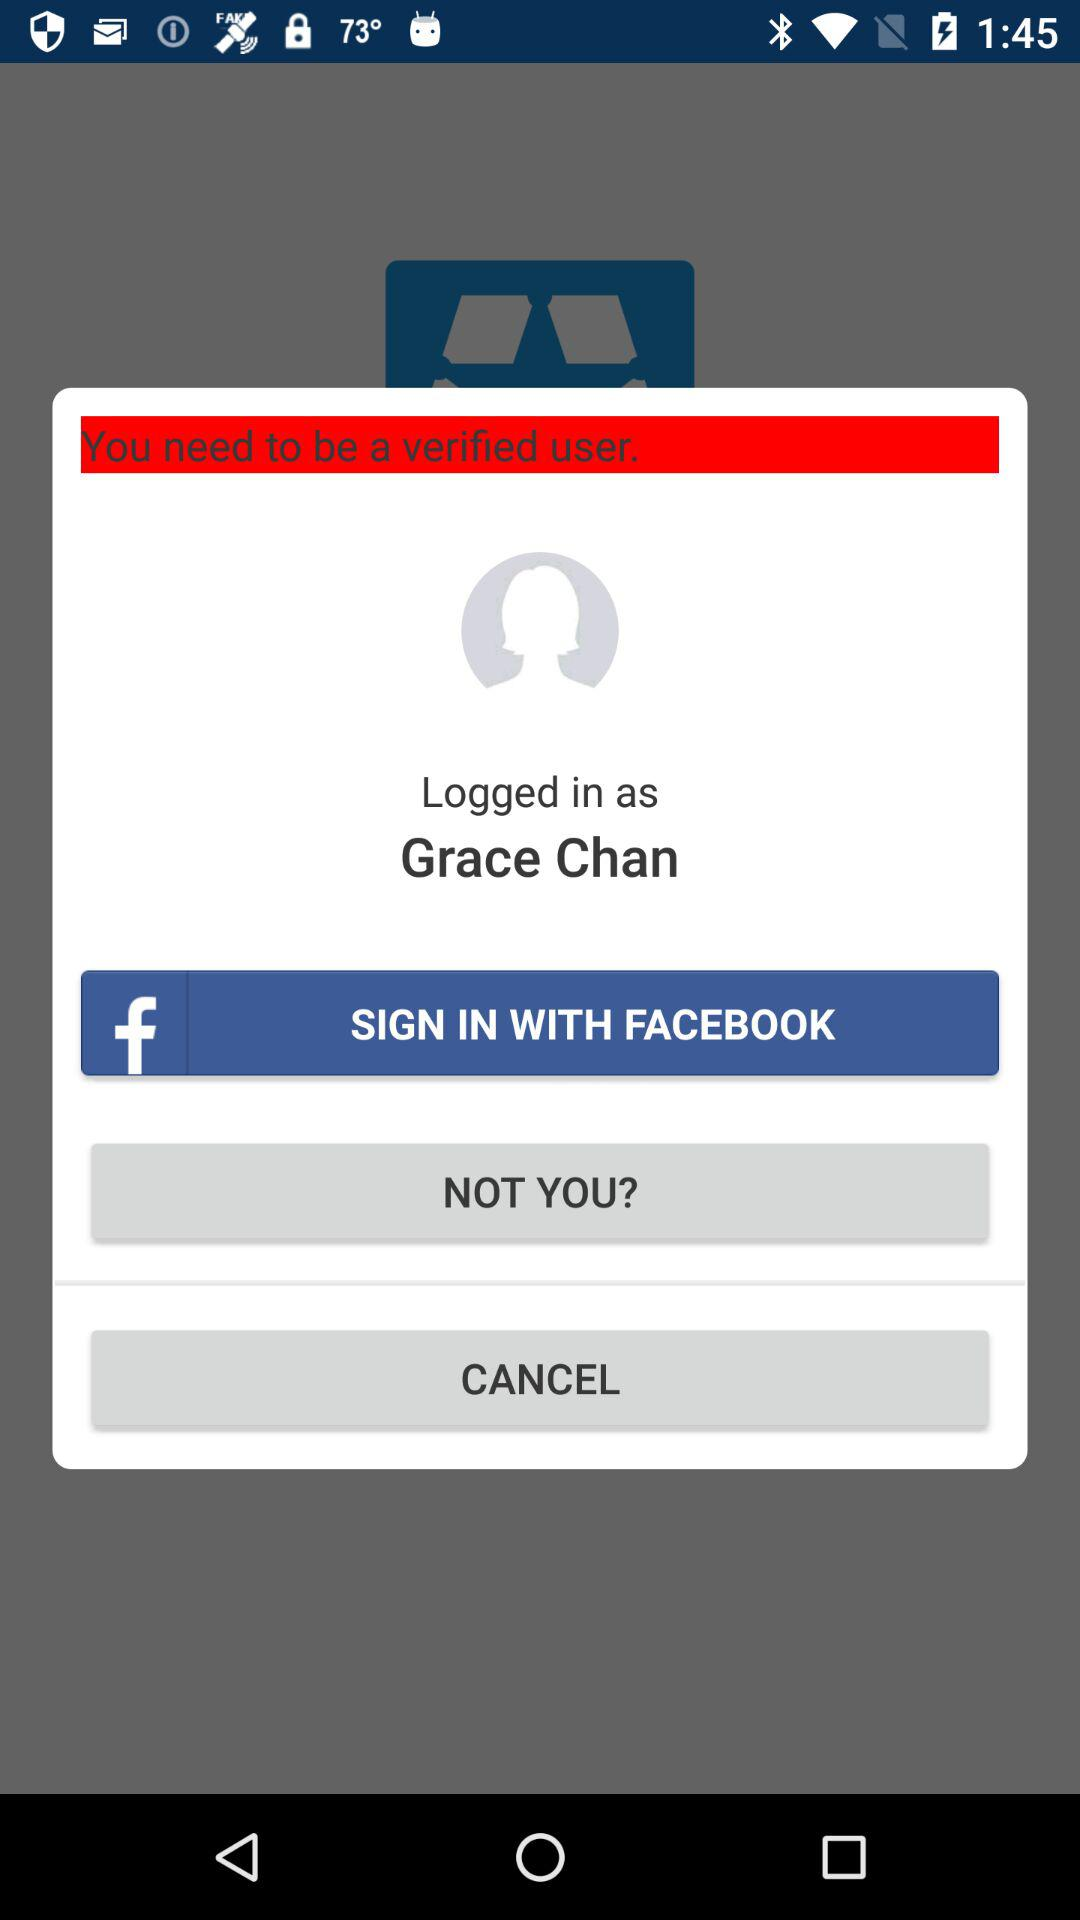What is the user name? The user name is Grace Chan. 